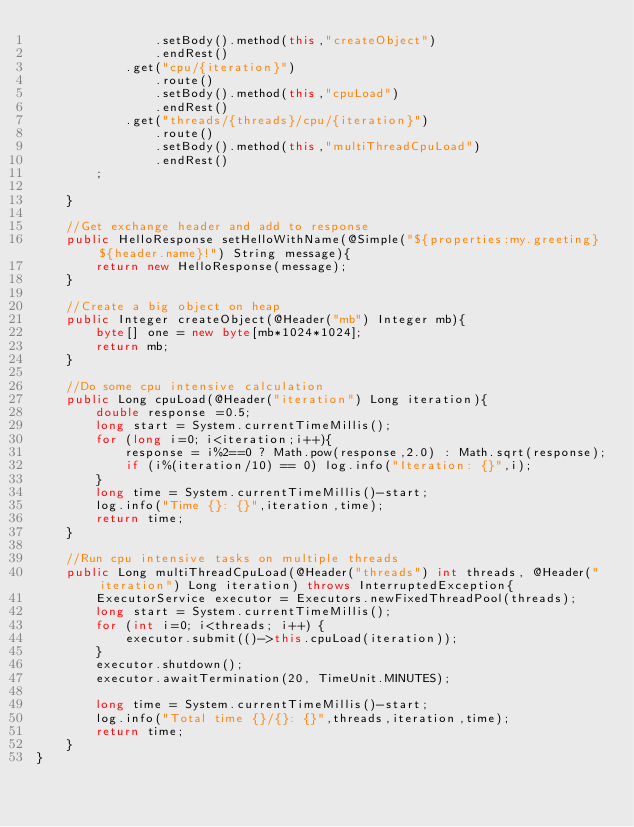<code> <loc_0><loc_0><loc_500><loc_500><_Java_>                .setBody().method(this,"createObject")
                .endRest()
            .get("cpu/{iteration}")
                .route()
                .setBody().method(this,"cpuLoad")
                .endRest()
            .get("threads/{threads}/cpu/{iteration}")
                .route()
                .setBody().method(this,"multiThreadCpuLoad")
                .endRest()
        ;

    }

    //Get exchange header and add to response
    public HelloResponse setHelloWithName(@Simple("${properties:my.greeting} ${header.name}!") String message){
        return new HelloResponse(message);
    }

    //Create a big object on heap
    public Integer createObject(@Header("mb") Integer mb){
        byte[] one = new byte[mb*1024*1024];
        return mb;
    }

    //Do some cpu intensive calculation
    public Long cpuLoad(@Header("iteration") Long iteration){
        double response =0.5;
        long start = System.currentTimeMillis();
        for (long i=0; i<iteration;i++){
            response = i%2==0 ? Math.pow(response,2.0) : Math.sqrt(response);
            if (i%(iteration/10) == 0) log.info("Iteration: {}",i);
        }
        long time = System.currentTimeMillis()-start;
        log.info("Time {}: {}",iteration,time);
        return time;
    }

    //Run cpu intensive tasks on multiple threads
    public Long multiThreadCpuLoad(@Header("threads") int threads, @Header("iteration") Long iteration) throws InterruptedException{
        ExecutorService executor = Executors.newFixedThreadPool(threads);
        long start = System.currentTimeMillis();
        for (int i=0; i<threads; i++) {
            executor.submit(()->this.cpuLoad(iteration));
        }
        executor.shutdown();
        executor.awaitTermination(20, TimeUnit.MINUTES);

        long time = System.currentTimeMillis()-start;
        log.info("Total time {}/{}: {}",threads,iteration,time);
        return time;
    }
}
</code> 